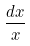Convert formula to latex. <formula><loc_0><loc_0><loc_500><loc_500>\frac { d x } { x }</formula> 